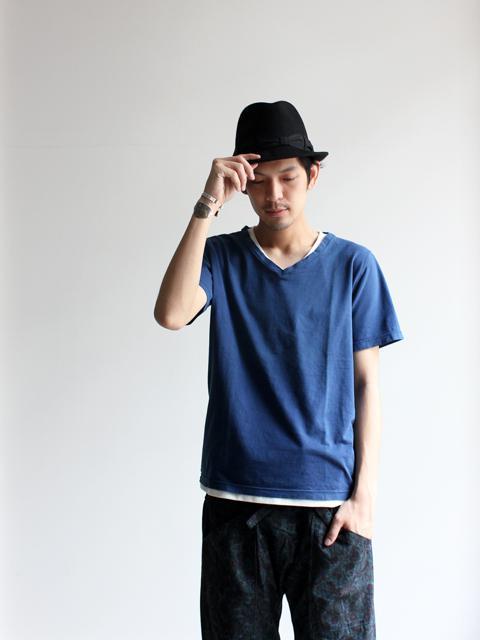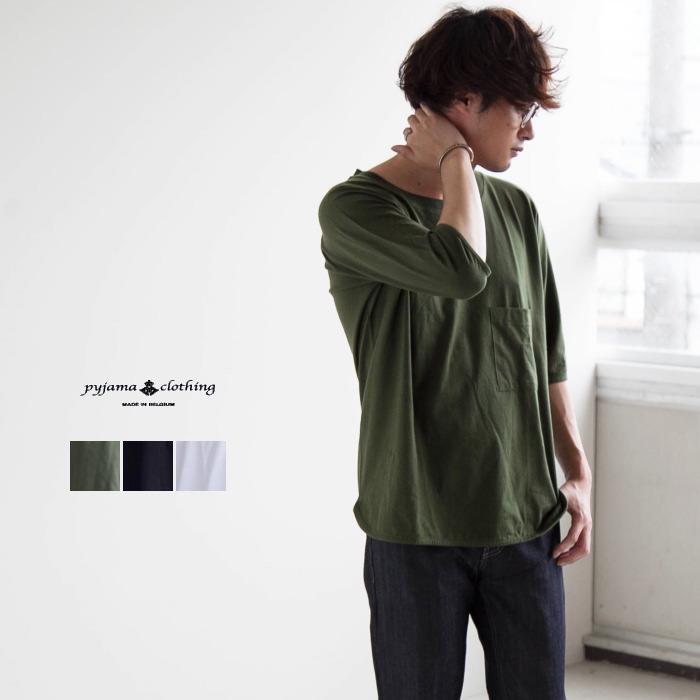The first image is the image on the left, the second image is the image on the right. Examine the images to the left and right. Is the description "One man is wearing something on his head." accurate? Answer yes or no. Yes. The first image is the image on the left, the second image is the image on the right. Evaluate the accuracy of this statement regarding the images: "The man in the left image is wearing a hat.". Is it true? Answer yes or no. Yes. 